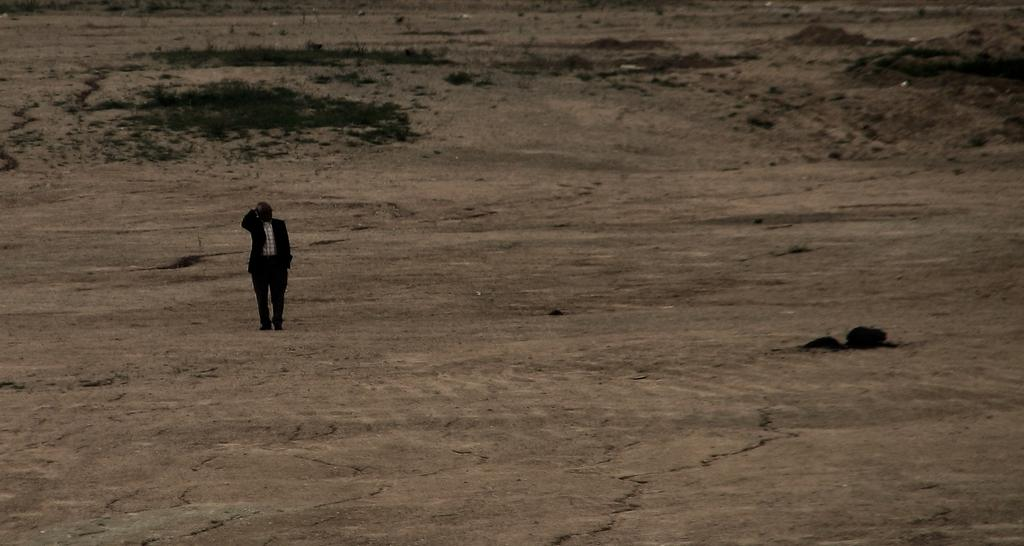What is the main subject of the image? There is a man standing in the image. Where is the man standing? The man is standing on the ground. What type of vegetation can be seen in the image? There is grass visible in the image. What color is the van parked next to the man in the image? There is no van present in the image; it only features a man standing on the grass. 